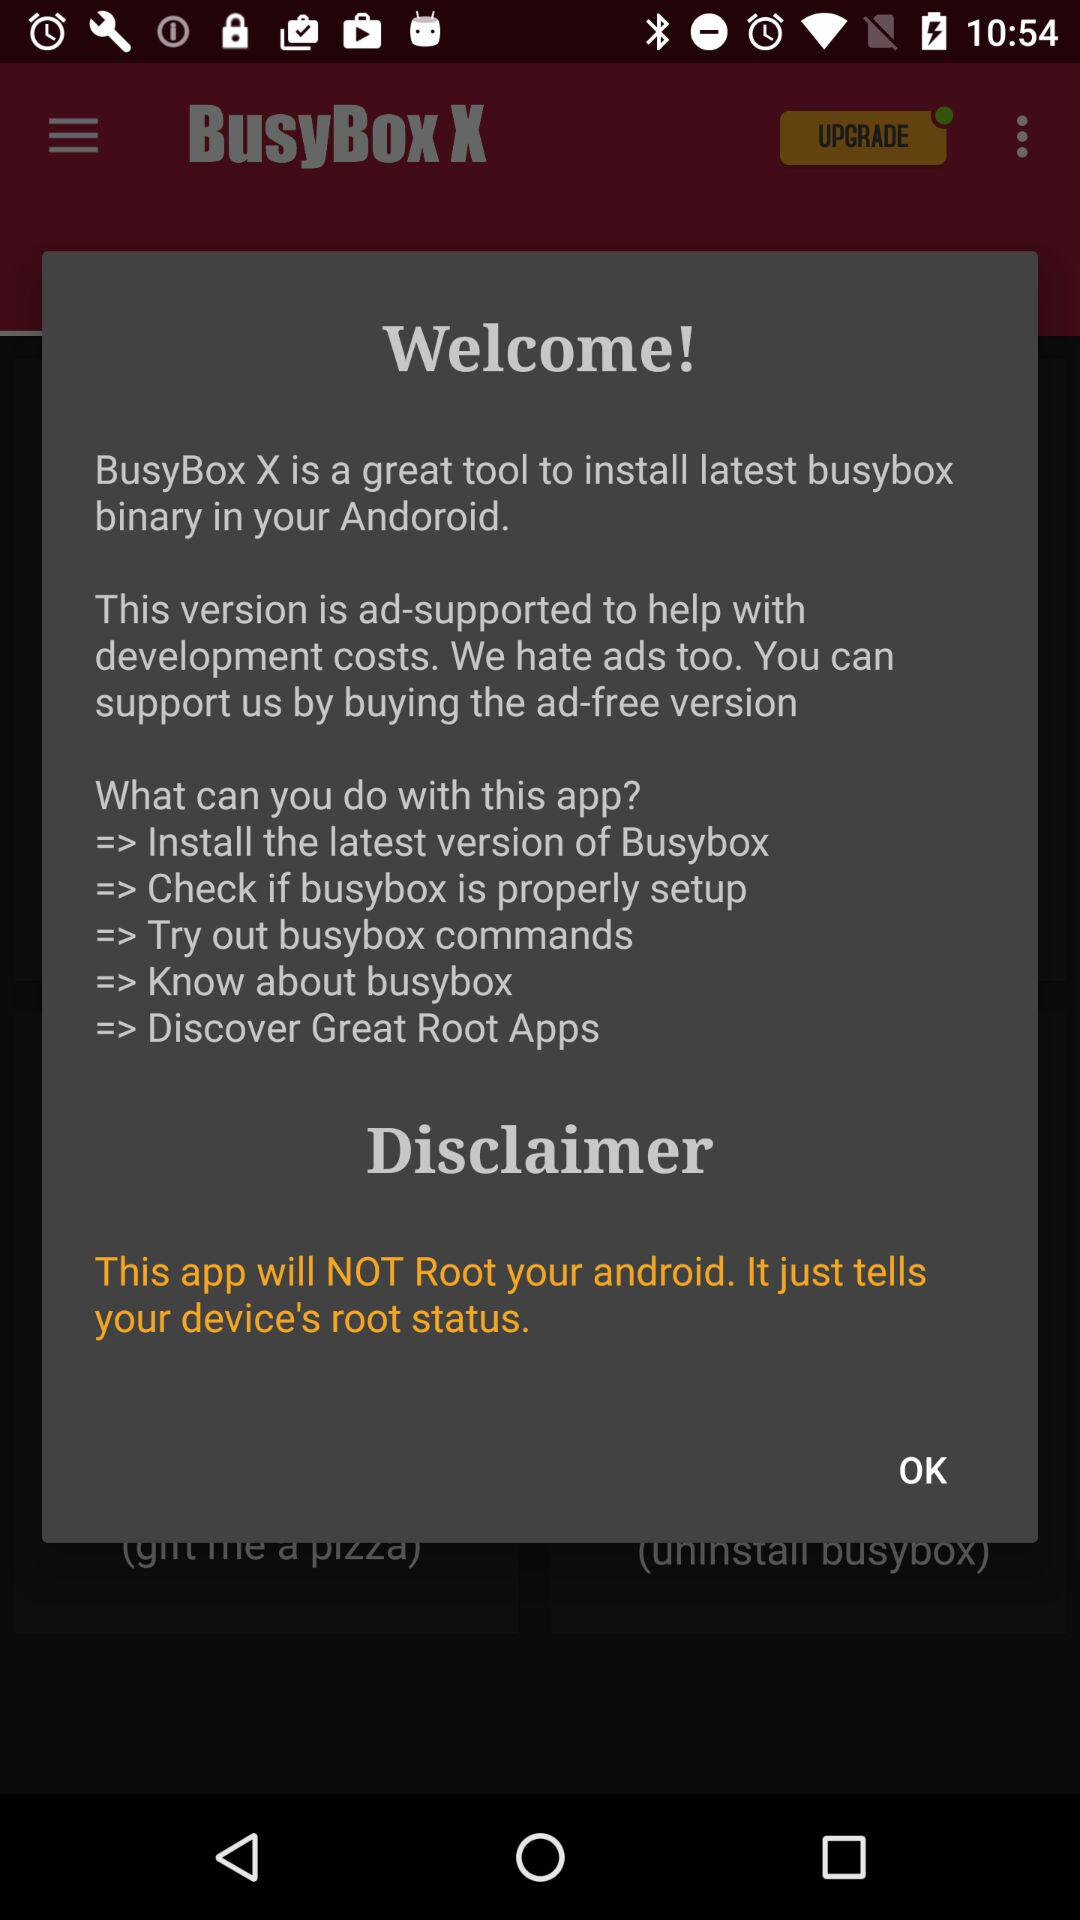What is the application name? The application name is "BusyBox X". 